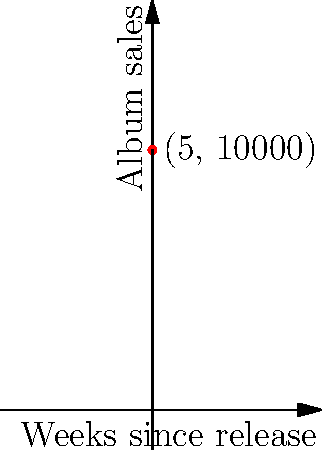Like, OMG! The Spice Girls just dropped their new album, and everyone's totally buying it! This graph shows their album sales over time. At 5 weeks after the release, what's the rate of change in sales? In other words, what's the slope of the tangent line to the curve at that point? Use the function $f(x) = 5000 + 2000x - 100x^2$, where $x$ is the number of weeks since release and $f(x)$ is the number of albums sold. Okay, let's break this down step by step:

1) We need to find the slope of the tangent line at $x = 5$. In calculus, this is the same as finding the derivative of the function at that point.

2) First, let's find the derivative of the function:
   $f(x) = 5000 + 2000x - 100x^2$
   $f'(x) = 2000 - 200x$

3) Now, we need to evaluate this derivative at $x = 5$:
   $f'(5) = 2000 - 200(5)$
   $f'(5) = 2000 - 1000$
   $f'(5) = 1000$

4) This means that at 5 weeks after the release, the rate of change of album sales (or the slope of the tangent line) is 1000 albums per week.

5) In the context of the question, this means that 5 weeks after the release, the Spice Girls' album sales are increasing at a rate of 1000 albums per week.
Answer: 1000 albums per week 